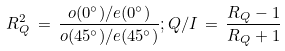<formula> <loc_0><loc_0><loc_500><loc_500>R ^ { 2 } _ { Q } \, = \, \frac { o ( 0 ^ { \circ } ) / e ( 0 ^ { \circ } ) } { o ( 4 5 ^ { \circ } ) / e ( 4 5 ^ { \circ } ) } ; Q / I \, = \, \frac { R _ { Q } - 1 } { R _ { Q } + 1 }</formula> 